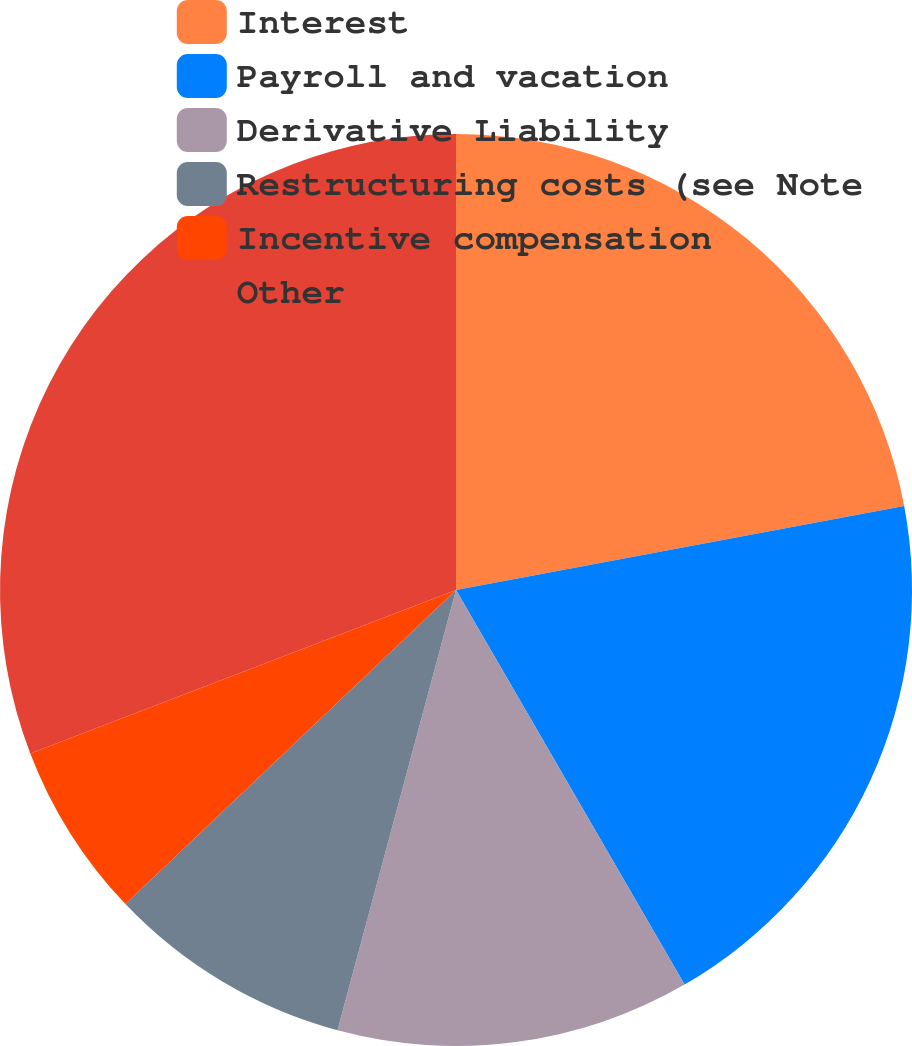Convert chart to OTSL. <chart><loc_0><loc_0><loc_500><loc_500><pie_chart><fcel>Interest<fcel>Payroll and vacation<fcel>Derivative Liability<fcel>Restructuring costs (see Note<fcel>Incentive compensation<fcel>Other<nl><fcel>22.05%<fcel>19.59%<fcel>12.54%<fcel>8.72%<fcel>6.26%<fcel>30.83%<nl></chart> 